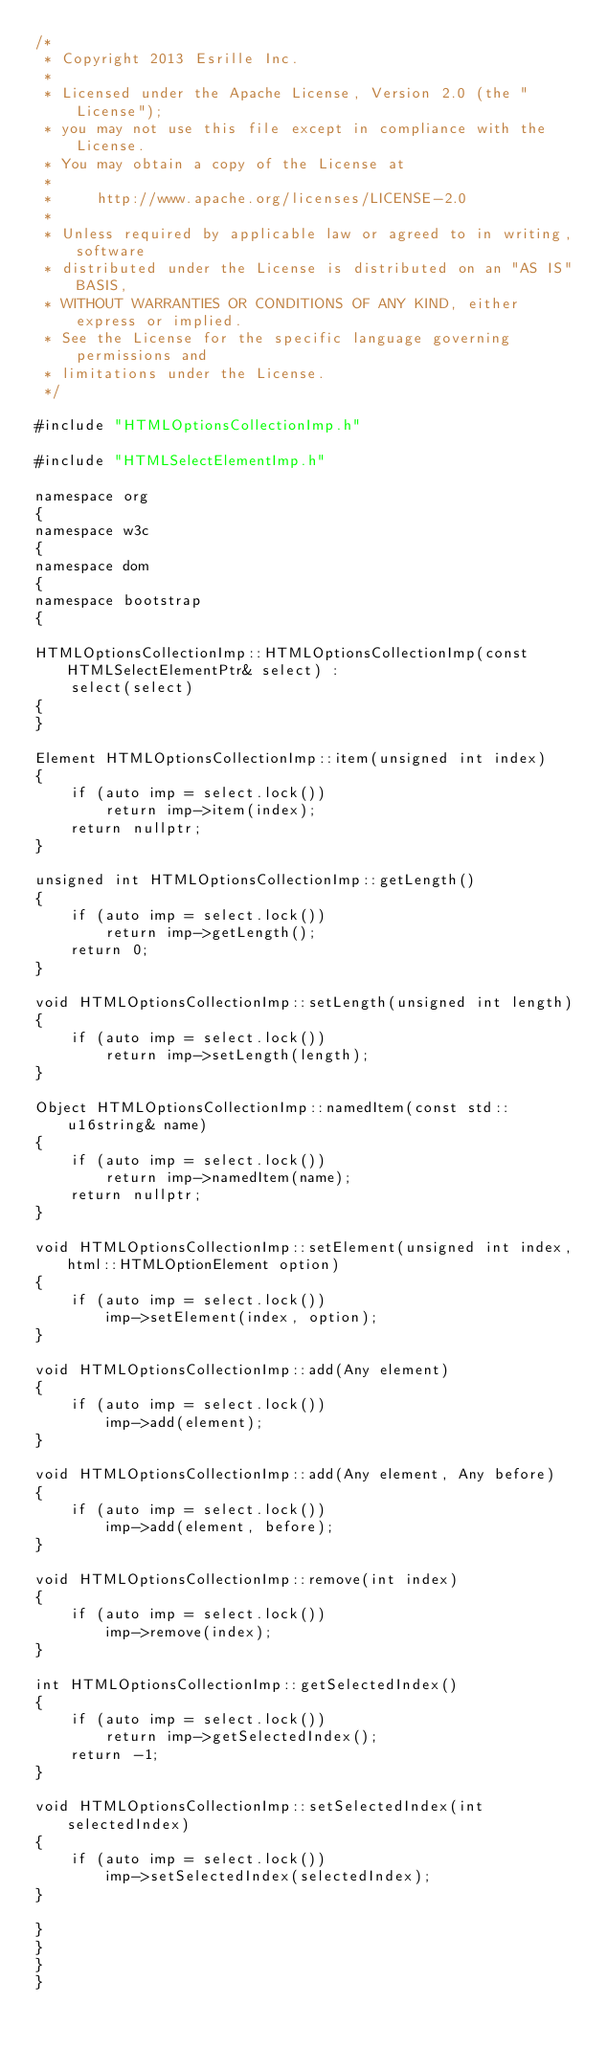Convert code to text. <code><loc_0><loc_0><loc_500><loc_500><_C++_>/*
 * Copyright 2013 Esrille Inc.
 *
 * Licensed under the Apache License, Version 2.0 (the "License");
 * you may not use this file except in compliance with the License.
 * You may obtain a copy of the License at
 *
 *     http://www.apache.org/licenses/LICENSE-2.0
 *
 * Unless required by applicable law or agreed to in writing, software
 * distributed under the License is distributed on an "AS IS" BASIS,
 * WITHOUT WARRANTIES OR CONDITIONS OF ANY KIND, either express or implied.
 * See the License for the specific language governing permissions and
 * limitations under the License.
 */

#include "HTMLOptionsCollectionImp.h"

#include "HTMLSelectElementImp.h"

namespace org
{
namespace w3c
{
namespace dom
{
namespace bootstrap
{

HTMLOptionsCollectionImp::HTMLOptionsCollectionImp(const HTMLSelectElementPtr& select) :
    select(select)
{
}

Element HTMLOptionsCollectionImp::item(unsigned int index)
{
    if (auto imp = select.lock())
        return imp->item(index);
    return nullptr;
}

unsigned int HTMLOptionsCollectionImp::getLength()
{
    if (auto imp = select.lock())
        return imp->getLength();
    return 0;
}

void HTMLOptionsCollectionImp::setLength(unsigned int length)
{
    if (auto imp = select.lock())
        return imp->setLength(length);
}

Object HTMLOptionsCollectionImp::namedItem(const std::u16string& name)
{
    if (auto imp = select.lock())
        return imp->namedItem(name);
    return nullptr;
}

void HTMLOptionsCollectionImp::setElement(unsigned int index, html::HTMLOptionElement option)
{
    if (auto imp = select.lock())
        imp->setElement(index, option);
}

void HTMLOptionsCollectionImp::add(Any element)
{
    if (auto imp = select.lock())
        imp->add(element);
}

void HTMLOptionsCollectionImp::add(Any element, Any before)
{
    if (auto imp = select.lock())
        imp->add(element, before);
}

void HTMLOptionsCollectionImp::remove(int index)
{
    if (auto imp = select.lock())
        imp->remove(index);
}

int HTMLOptionsCollectionImp::getSelectedIndex()
{
    if (auto imp = select.lock())
        return imp->getSelectedIndex();
    return -1;
}

void HTMLOptionsCollectionImp::setSelectedIndex(int selectedIndex)
{
    if (auto imp = select.lock())
        imp->setSelectedIndex(selectedIndex);
}

}
}
}
}
</code> 